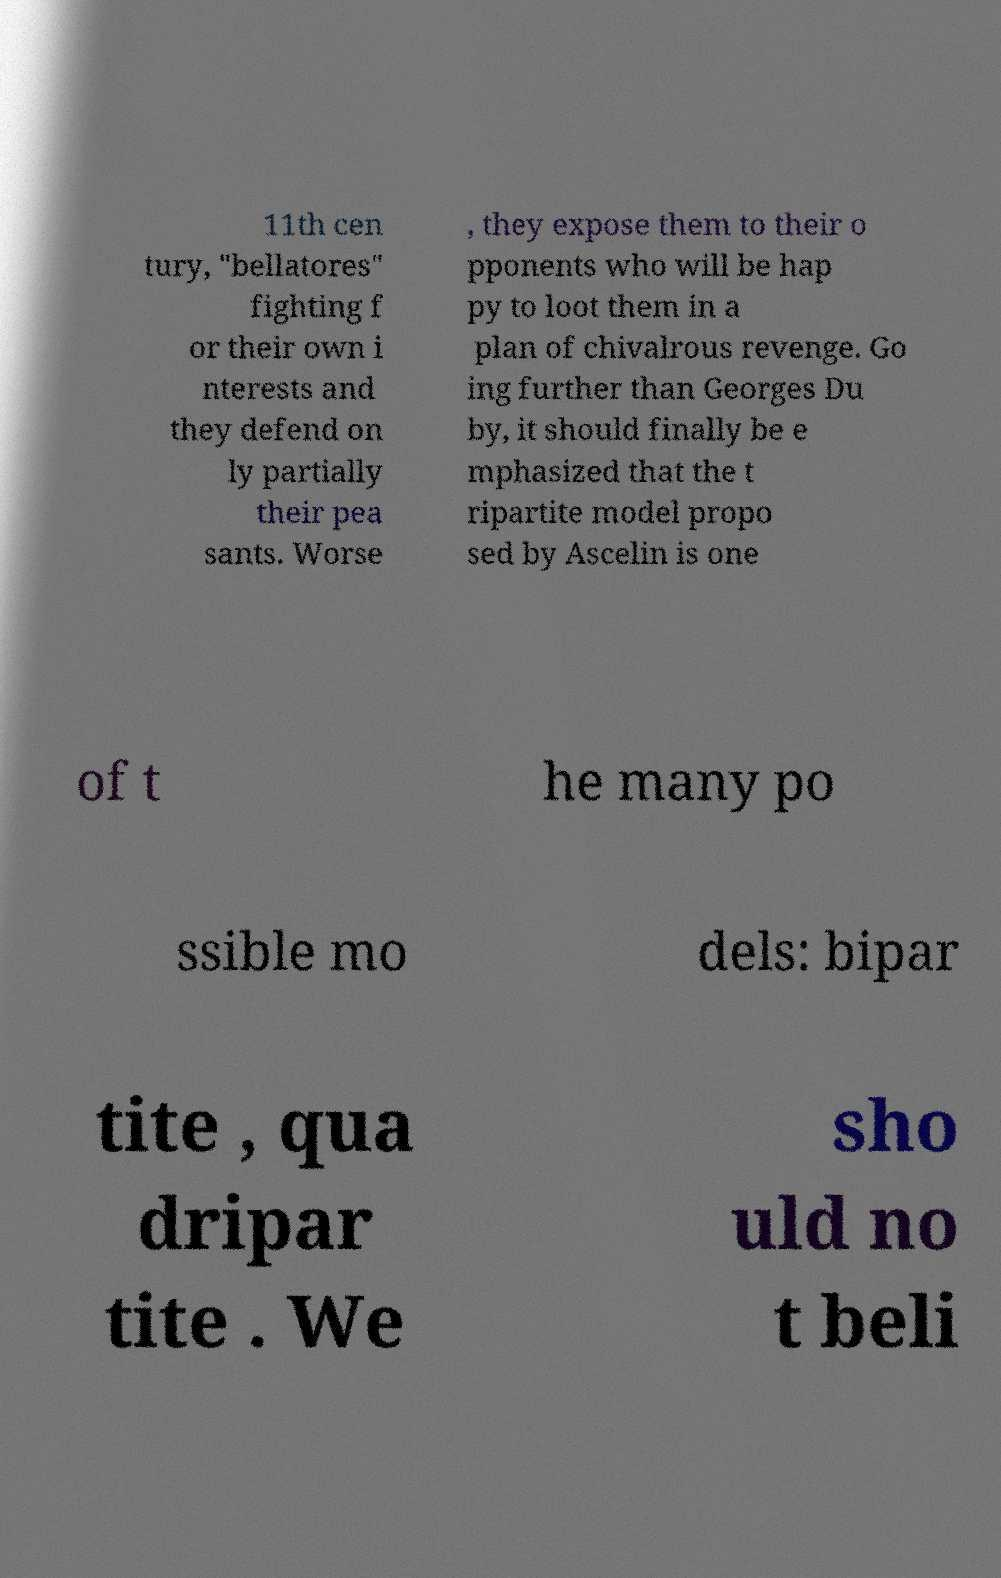Can you accurately transcribe the text from the provided image for me? 11th cen tury, "bellatores" fighting f or their own i nterests and they defend on ly partially their pea sants. Worse , they expose them to their o pponents who will be hap py to loot them in a plan of chivalrous revenge. Go ing further than Georges Du by, it should finally be e mphasized that the t ripartite model propo sed by Ascelin is one of t he many po ssible mo dels: bipar tite , qua dripar tite . We sho uld no t beli 